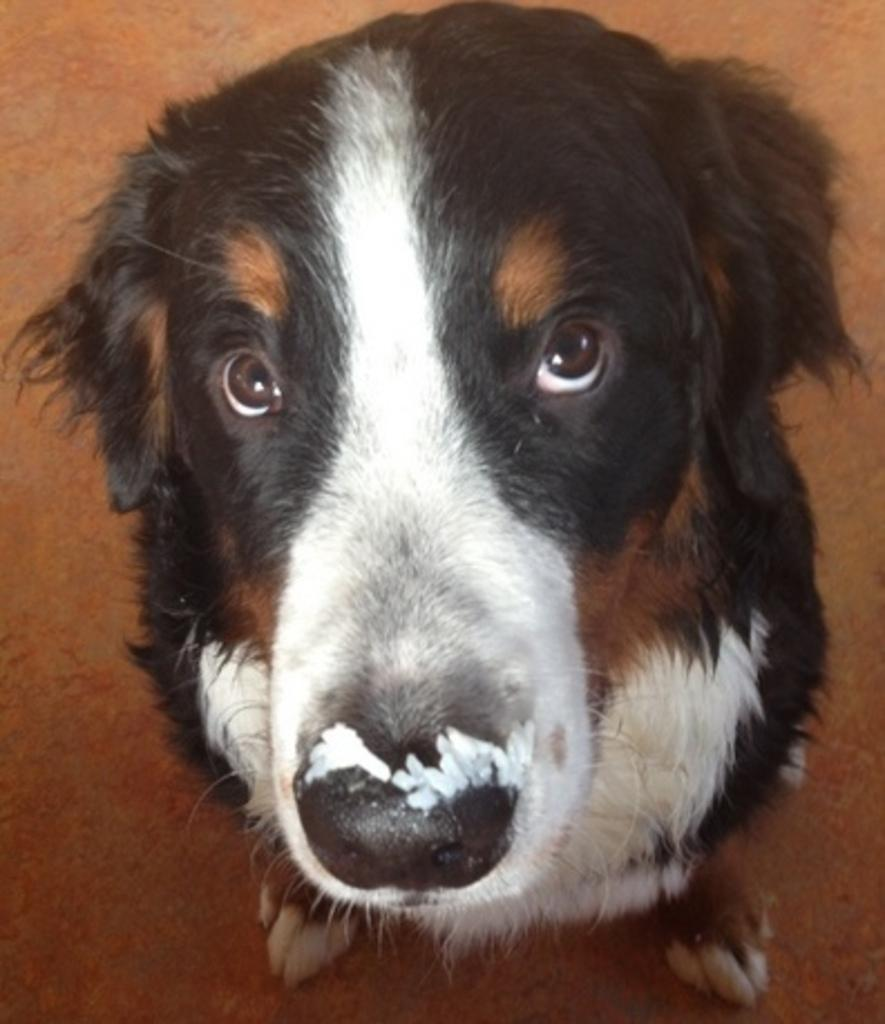What type of animal is in the image? There is a brown dog in the image. What position is the dog in? The dog is sitting in the front. What is the dog doing in the image? The dog is looking at the camera. What type of flooring is visible in the background? There is brown carpet flooring in the background. What type of jar is the dog holding in the image? There is no jar present in the image; the dog is simply sitting and looking at the camera. 